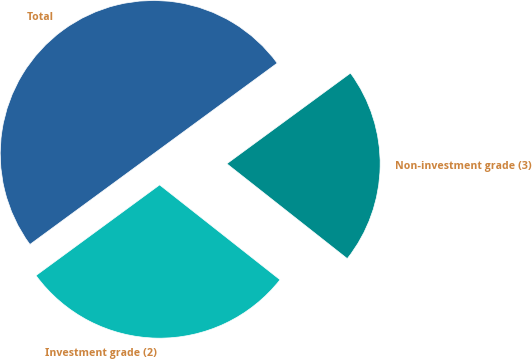Convert chart. <chart><loc_0><loc_0><loc_500><loc_500><pie_chart><fcel>Investment grade (2)<fcel>Non-investment grade (3)<fcel>Total<nl><fcel>29.31%<fcel>20.69%<fcel>50.0%<nl></chart> 